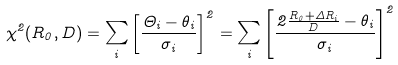<formula> <loc_0><loc_0><loc_500><loc_500>\chi ^ { 2 } ( R _ { 0 } , D ) = \sum _ { i } \left [ \frac { \Theta _ { i } - \theta _ { i } } { \sigma _ { i } } \right ] ^ { 2 } = \sum _ { i } \left [ \frac { 2 \frac { R _ { 0 } + \Delta R _ { i } } { D } - \theta _ { i } } { \sigma _ { i } } \right ] ^ { 2 }</formula> 